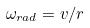Convert formula to latex. <formula><loc_0><loc_0><loc_500><loc_500>\omega _ { r a d } = v / r</formula> 